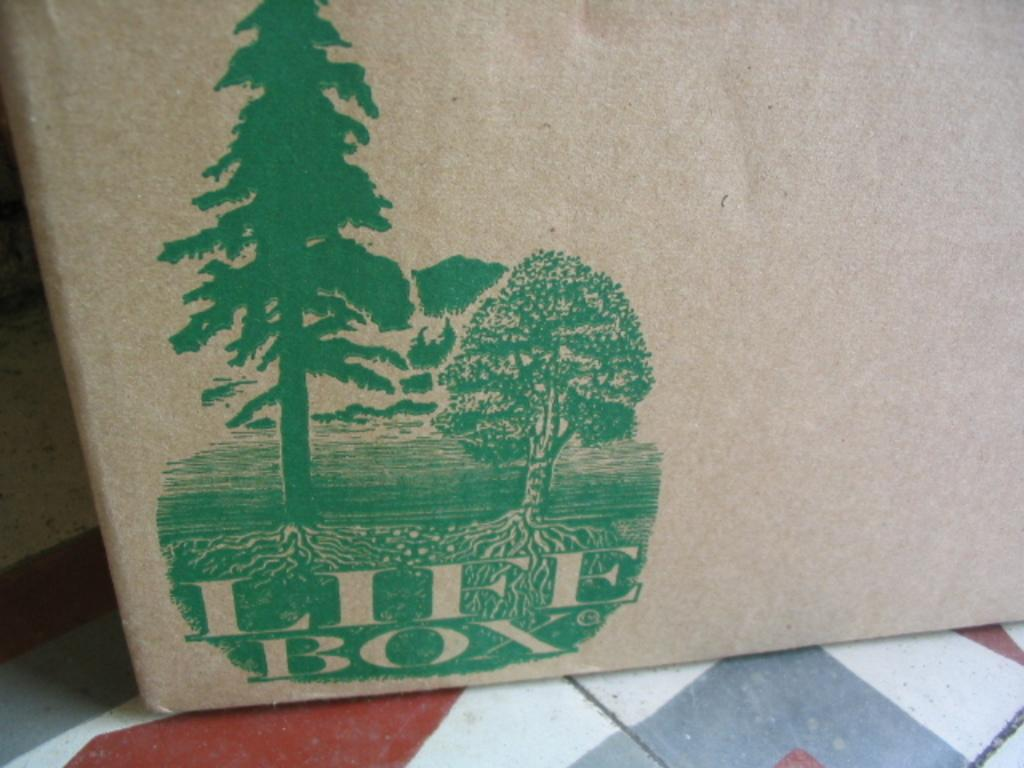Provide a one-sentence caption for the provided image. Brown bag showing trees and words that say Life Box. 